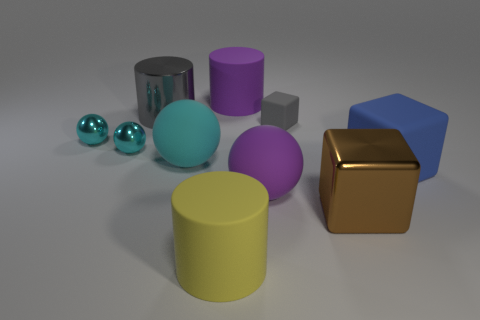There is a big purple rubber thing that is behind the big purple rubber ball; does it have the same shape as the metal thing that is to the right of the large purple ball?
Your answer should be compact. No. Is there a big purple object that has the same material as the large cyan thing?
Your response must be concise. Yes. Is the object that is in front of the brown metal thing made of the same material as the large blue object?
Provide a succinct answer. Yes. Is the number of small gray blocks in front of the big brown cube greater than the number of brown metal things that are behind the large cyan rubber sphere?
Provide a short and direct response. No. There is a metal cube that is the same size as the gray metallic object; what is its color?
Give a very brief answer. Brown. Are there any metal cylinders of the same color as the small rubber object?
Your response must be concise. Yes. There is a big cylinder in front of the gray matte block; does it have the same color as the big shiny thing in front of the big gray cylinder?
Your response must be concise. No. There is a large cylinder that is in front of the blue matte block; what is it made of?
Provide a succinct answer. Rubber. The other block that is the same material as the blue block is what color?
Make the answer very short. Gray. How many gray metal things are the same size as the purple cylinder?
Your response must be concise. 1. 